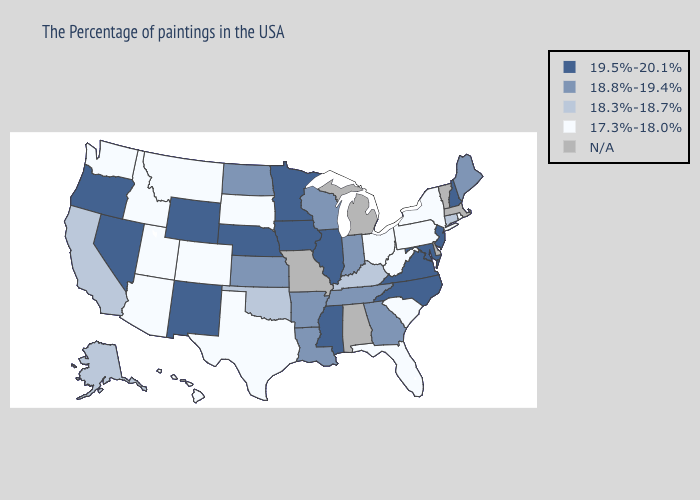Which states hav the highest value in the Northeast?
Write a very short answer. New Hampshire, New Jersey. Which states hav the highest value in the Northeast?
Be succinct. New Hampshire, New Jersey. Name the states that have a value in the range 18.3%-18.7%?
Write a very short answer. Connecticut, Kentucky, Oklahoma, California, Alaska. What is the highest value in states that border Arizona?
Be succinct. 19.5%-20.1%. What is the value of Colorado?
Give a very brief answer. 17.3%-18.0%. Does the map have missing data?
Give a very brief answer. Yes. What is the value of Virginia?
Keep it brief. 19.5%-20.1%. What is the highest value in states that border Indiana?
Answer briefly. 19.5%-20.1%. Does New Jersey have the highest value in the USA?
Quick response, please. Yes. Does Nevada have the lowest value in the West?
Short answer required. No. Name the states that have a value in the range 19.5%-20.1%?
Concise answer only. New Hampshire, New Jersey, Maryland, Virginia, North Carolina, Illinois, Mississippi, Minnesota, Iowa, Nebraska, Wyoming, New Mexico, Nevada, Oregon. What is the highest value in the MidWest ?
Quick response, please. 19.5%-20.1%. Name the states that have a value in the range 19.5%-20.1%?
Give a very brief answer. New Hampshire, New Jersey, Maryland, Virginia, North Carolina, Illinois, Mississippi, Minnesota, Iowa, Nebraska, Wyoming, New Mexico, Nevada, Oregon. 